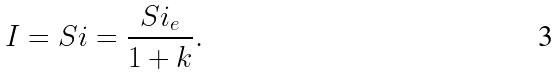Convert formula to latex. <formula><loc_0><loc_0><loc_500><loc_500>I = S i = \frac { S i _ { e } } { 1 + k } .</formula> 